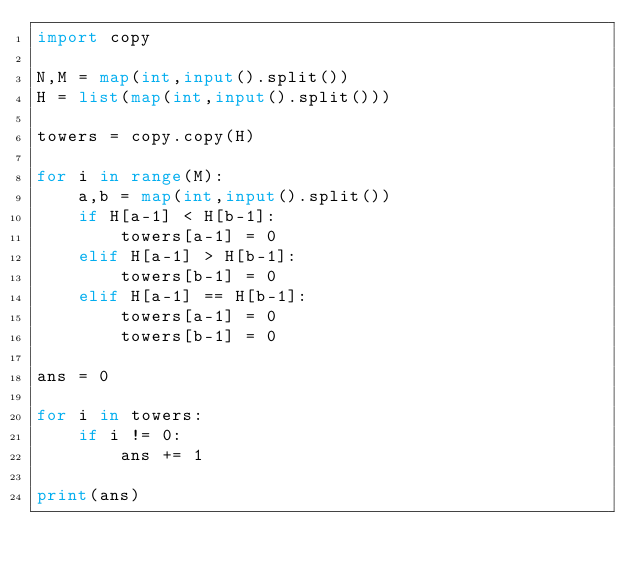<code> <loc_0><loc_0><loc_500><loc_500><_Python_>import copy

N,M = map(int,input().split())
H = list(map(int,input().split()))

towers = copy.copy(H)

for i in range(M):
    a,b = map(int,input().split())
    if H[a-1] < H[b-1]:
        towers[a-1] = 0
    elif H[a-1] > H[b-1]:
        towers[b-1] = 0
    elif H[a-1] == H[b-1]:
        towers[a-1] = 0
        towers[b-1] = 0

ans = 0

for i in towers:
    if i != 0:
        ans += 1

print(ans)</code> 